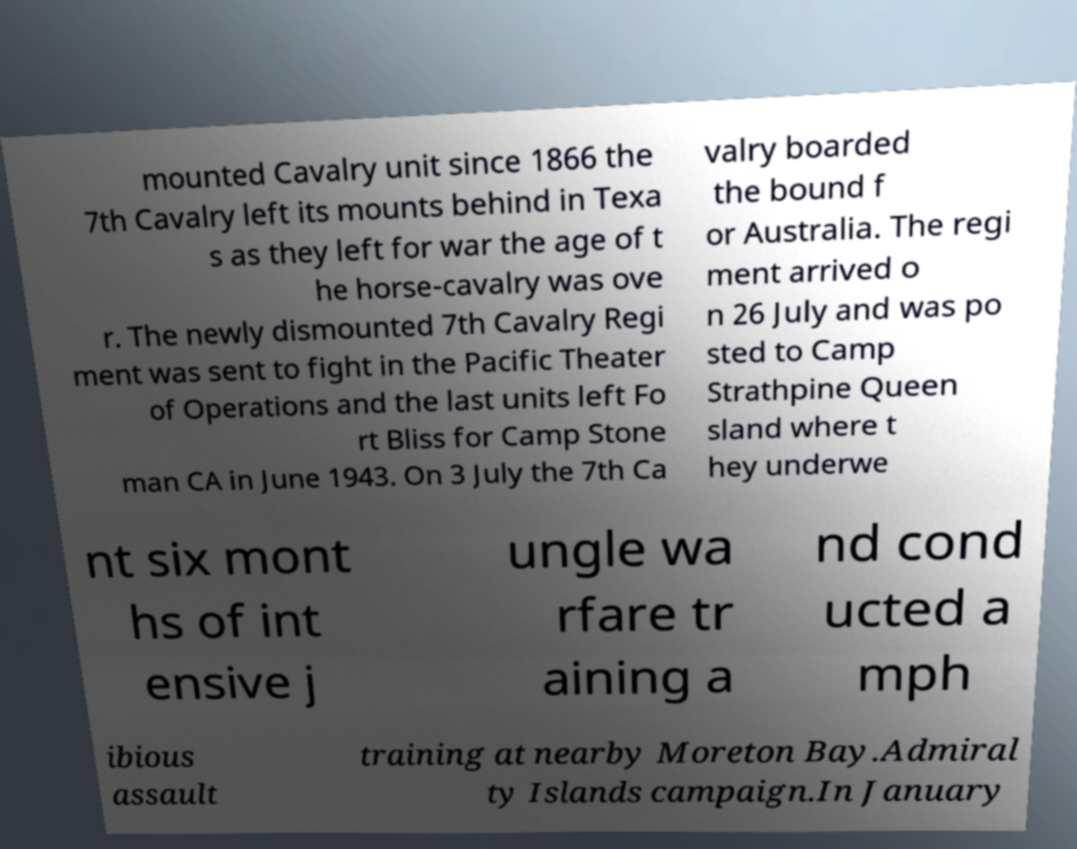Please read and relay the text visible in this image. What does it say? mounted Cavalry unit since 1866 the 7th Cavalry left its mounts behind in Texa s as they left for war the age of t he horse-cavalry was ove r. The newly dismounted 7th Cavalry Regi ment was sent to fight in the Pacific Theater of Operations and the last units left Fo rt Bliss for Camp Stone man CA in June 1943. On 3 July the 7th Ca valry boarded the bound f or Australia. The regi ment arrived o n 26 July and was po sted to Camp Strathpine Queen sland where t hey underwe nt six mont hs of int ensive j ungle wa rfare tr aining a nd cond ucted a mph ibious assault training at nearby Moreton Bay.Admiral ty Islands campaign.In January 